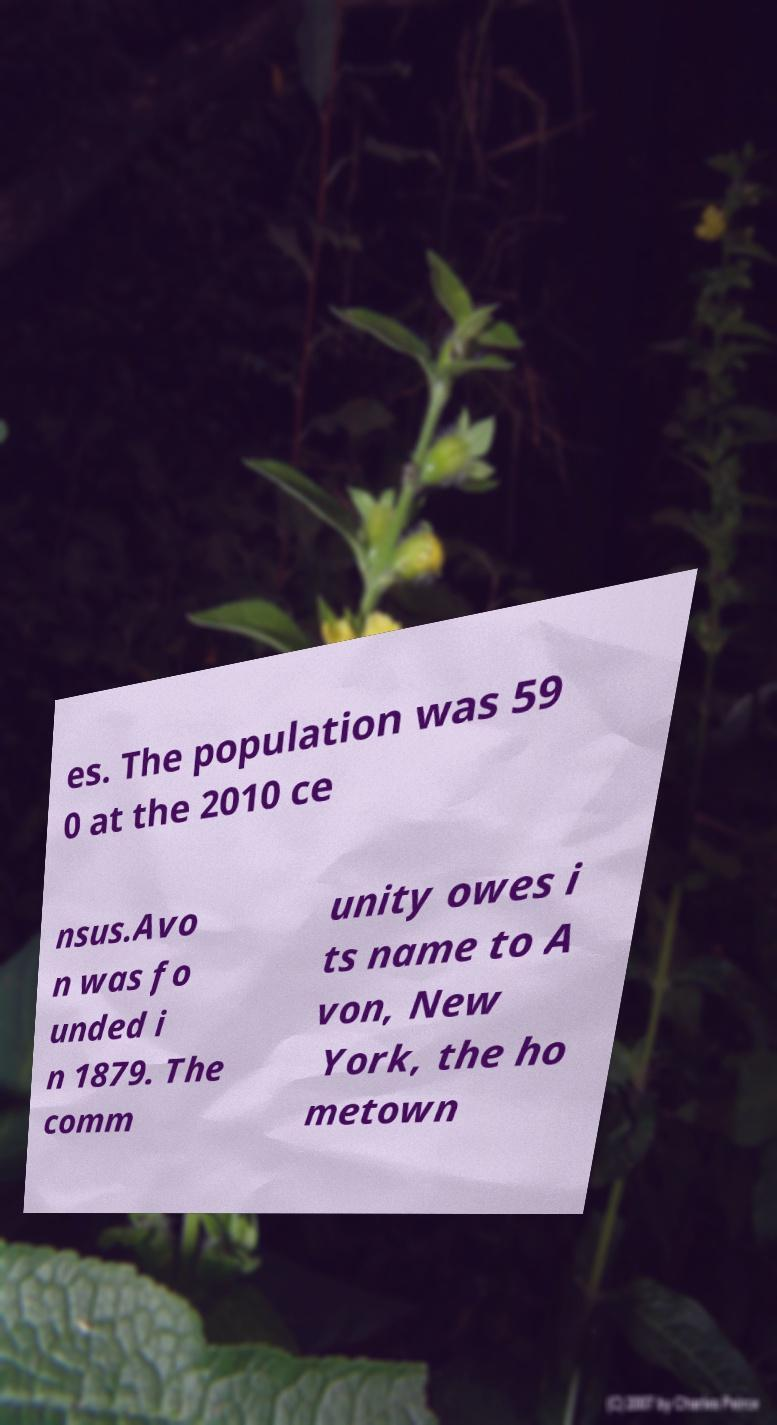Please identify and transcribe the text found in this image. es. The population was 59 0 at the 2010 ce nsus.Avo n was fo unded i n 1879. The comm unity owes i ts name to A von, New York, the ho metown 